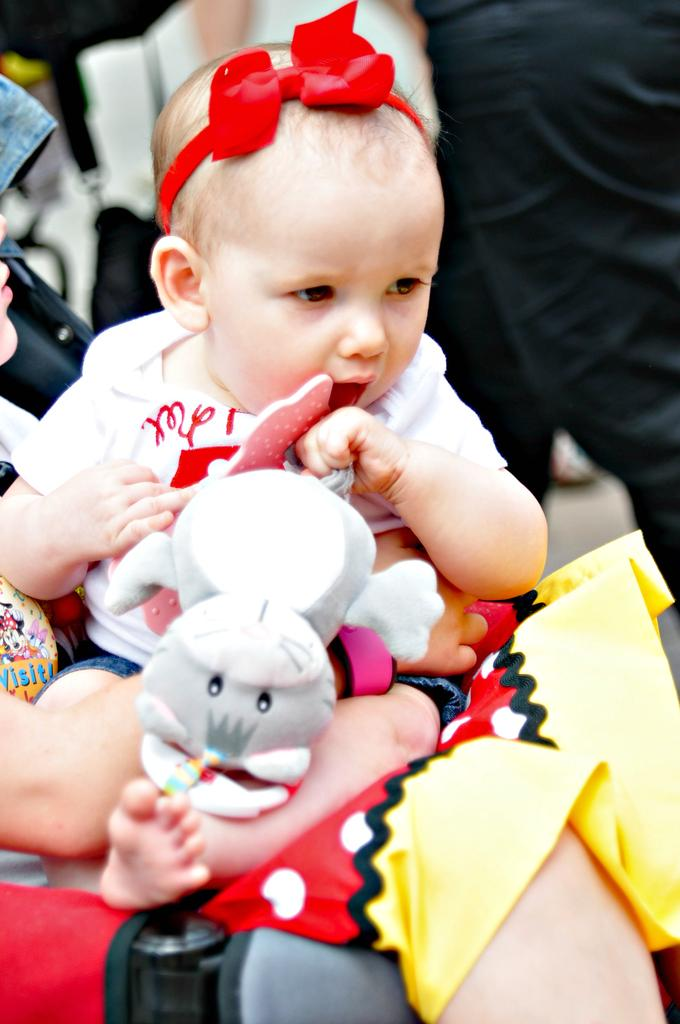What is the main subject of the image? The main subject of the image is a kid. What is the kid holding in the image? The kid is holding a toy. How is the kid positioned in the image? The kid is sitting on a person. What is the person holding the kid doing with their hands? The person holding the kid is using their hands. Can you describe the background of the image? There are other persons visible in the background of the image. What type of drug is the kid using in the image? There is no drug present in the image; the kid is holding a toy. How many crows can be seen in the image? There are no crows visible in the image. 